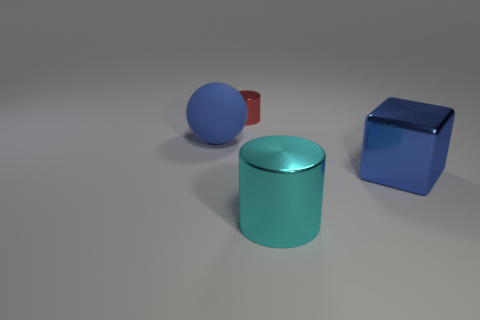Add 1 blue metal things. How many objects exist? 5 Subtract all balls. How many objects are left? 3 Subtract all yellow blocks. Subtract all cyan shiny things. How many objects are left? 3 Add 1 big metal cylinders. How many big metal cylinders are left? 2 Add 1 cyan objects. How many cyan objects exist? 2 Subtract 0 cyan balls. How many objects are left? 4 